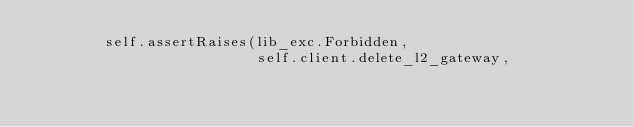Convert code to text. <code><loc_0><loc_0><loc_500><loc_500><_Python_>        self.assertRaises(lib_exc.Forbidden,
                          self.client.delete_l2_gateway,</code> 